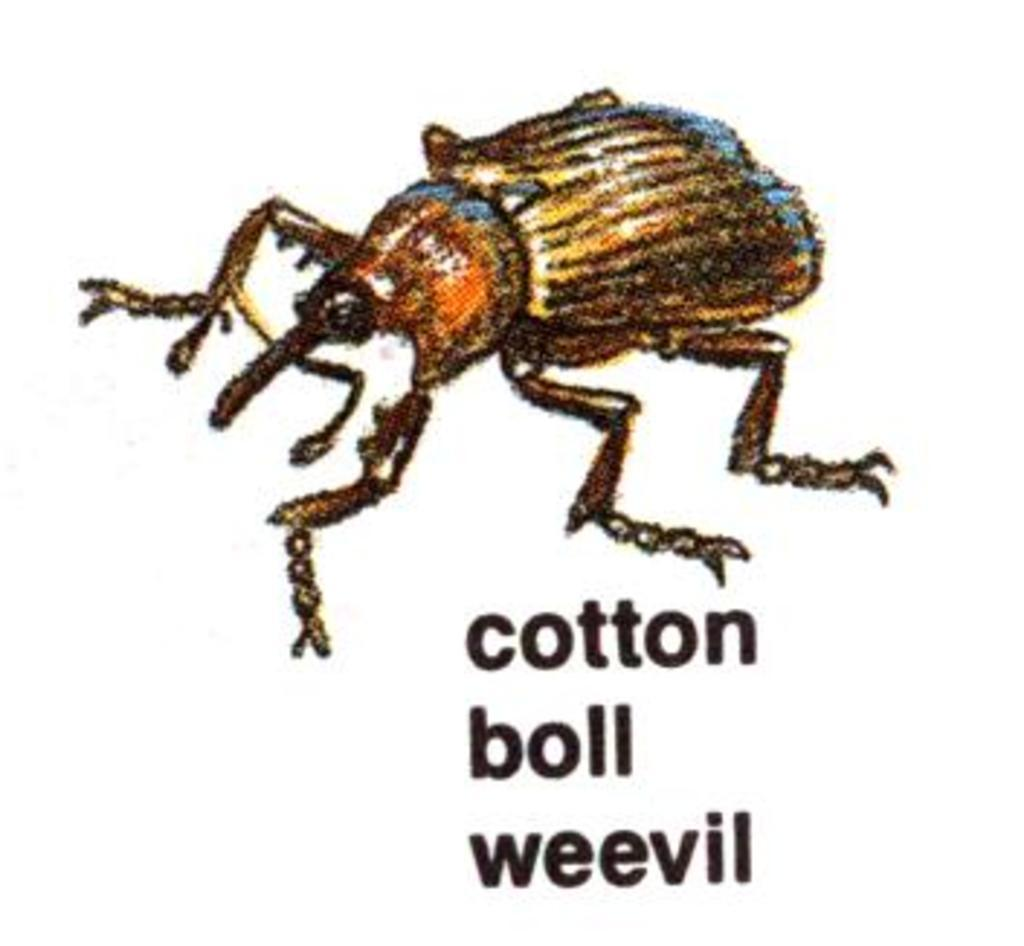What is the main subject of the image? The main subject of the image is an art of an insect. What additional information is provided about the insect in the image? The name of the insect is present in the image. What type of bait is used to attract the insect's sister in the image? There is no mention of a sister or bait in the image; it only features an art of an insect with its name. 